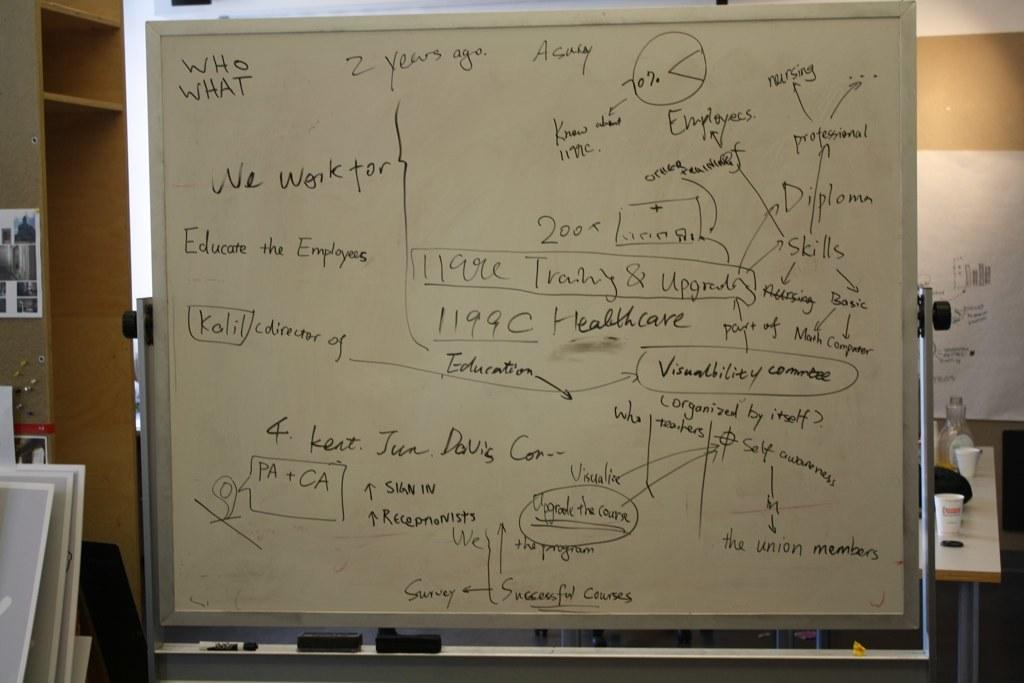<image>
Give a short and clear explanation of the subsequent image. A white board has the words who and what written in the corner. 